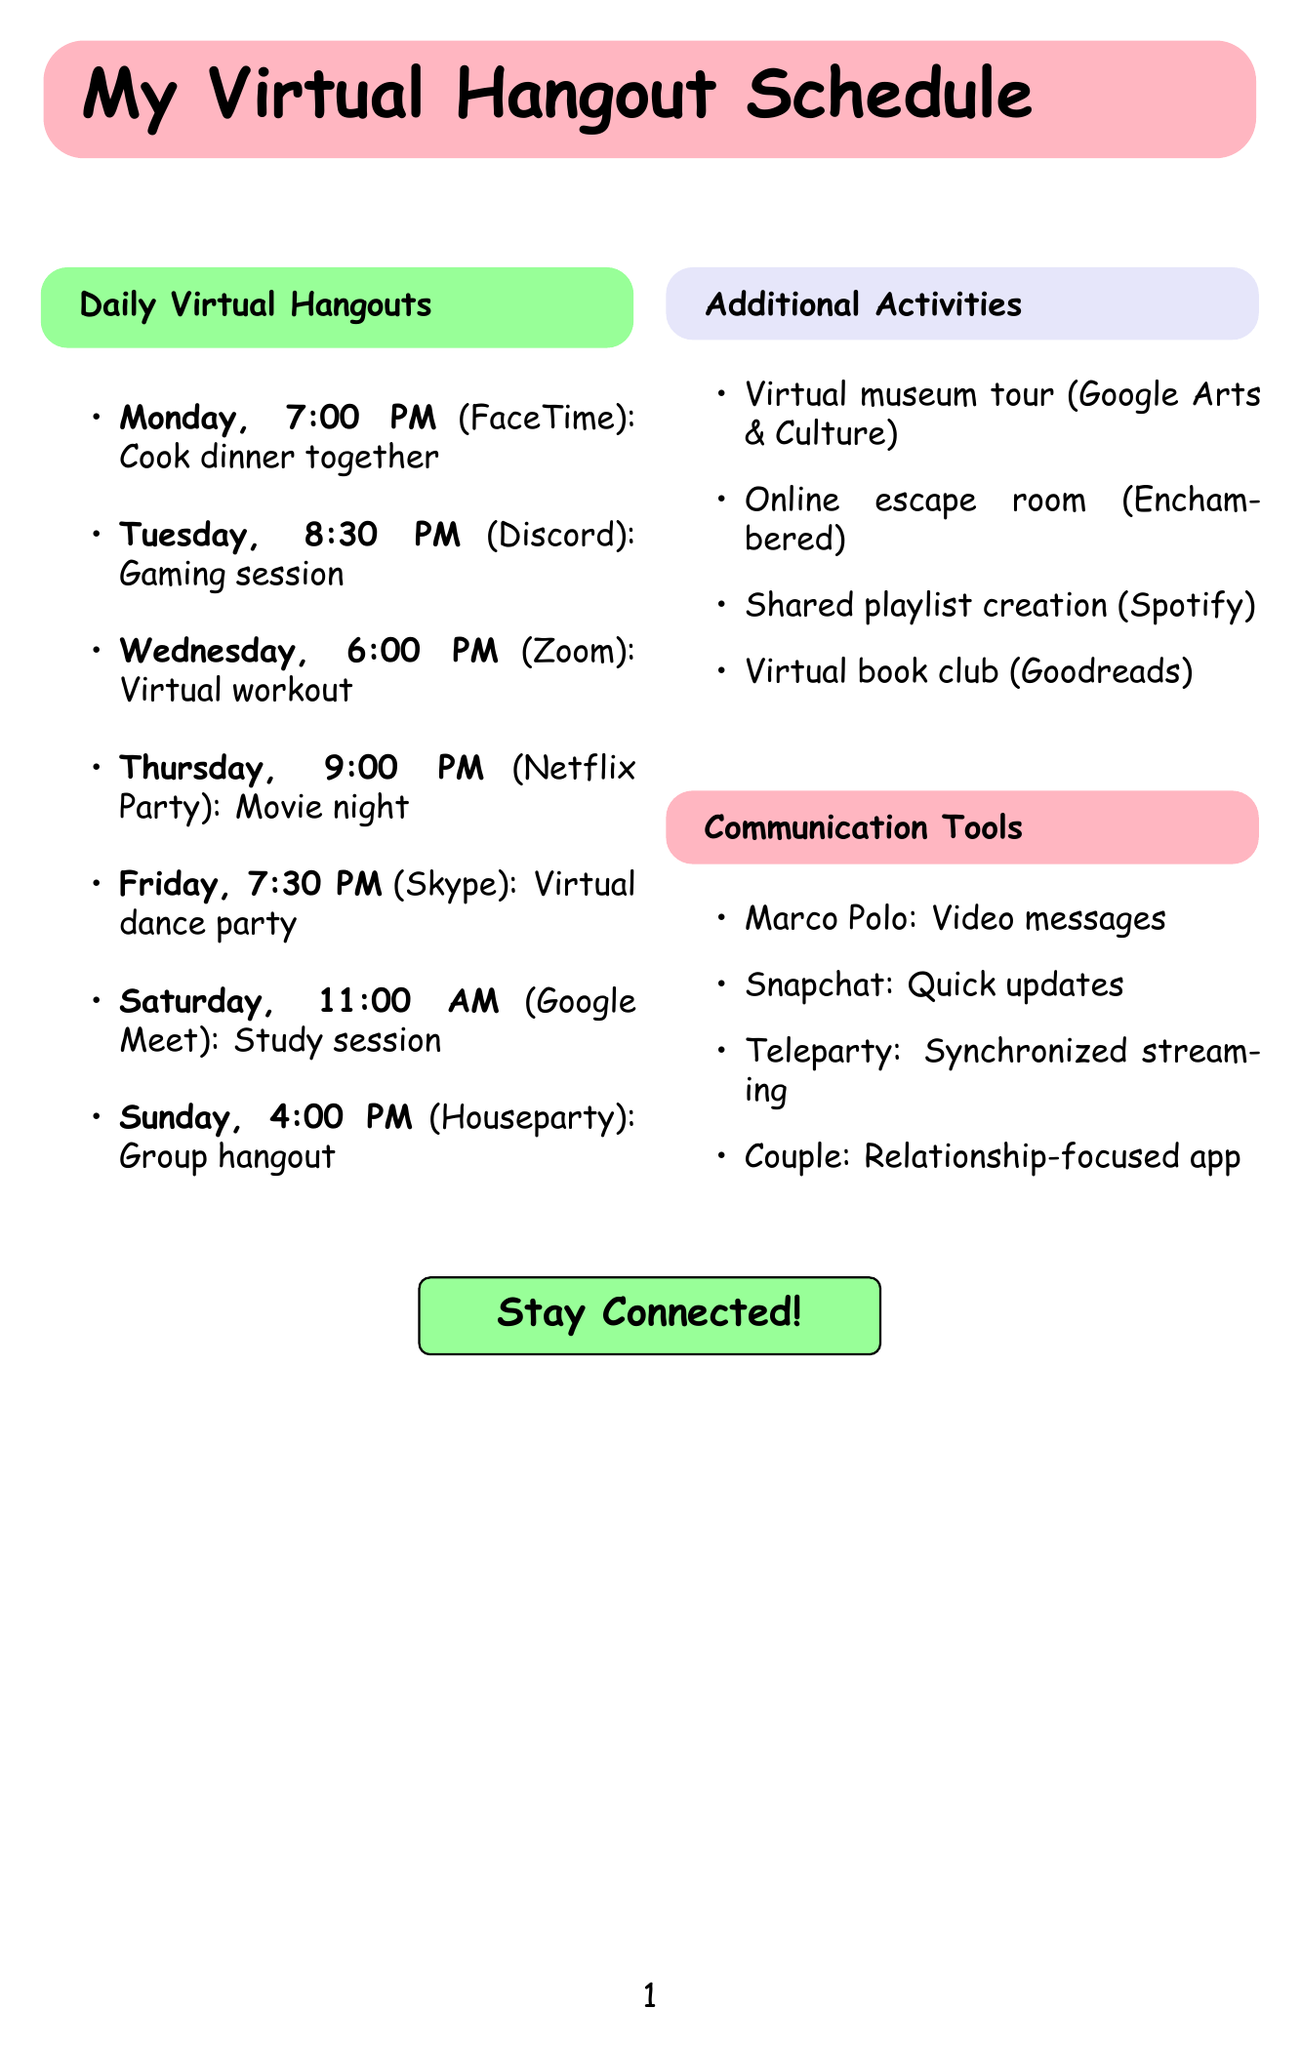What day and time is the virtual workout scheduled? The virtual workout is scheduled for Wednesday at 6:00 PM according to the document.
Answer: Wednesday, 6:00 PM Which platform is used for the movie night activity? The document specifies that Netflix Party is used for the movie night activity.
Answer: Netflix Party What is the activity planned for Friday at 7:30 PM? The document states that a virtual dance party is planned for that time.
Answer: Virtual dance party How many different platforms are mentioned in the daily virtual hangouts? The document lists seven different platforms used for the activities, making for a total of seven.
Answer: Seven Which day includes a study session and what time is it? The study session is scheduled on Saturday at 11:00 AM, as per the document.
Answer: Saturday, 11:00 AM What is one of the additional activities that can be done on Google Arts & Culture? The document states that a virtual museum tour is one of the additional activities available on that platform.
Answer: Virtual museum tour On which platform can a couple create a shared playlist? According to the document, Spotify is the platform where a shared playlist can be created.
Answer: Spotify What type of app is Marco Polo described as? The document describes Marco Polo as an app for sending video messages.
Answer: Video messages 